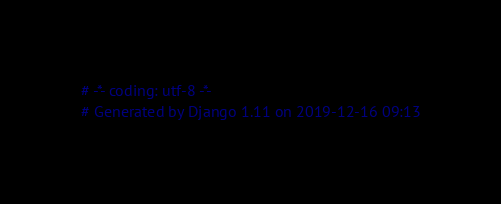<code> <loc_0><loc_0><loc_500><loc_500><_Python_># -*- coding: utf-8 -*-
# Generated by Django 1.11 on 2019-12-16 09:13</code> 